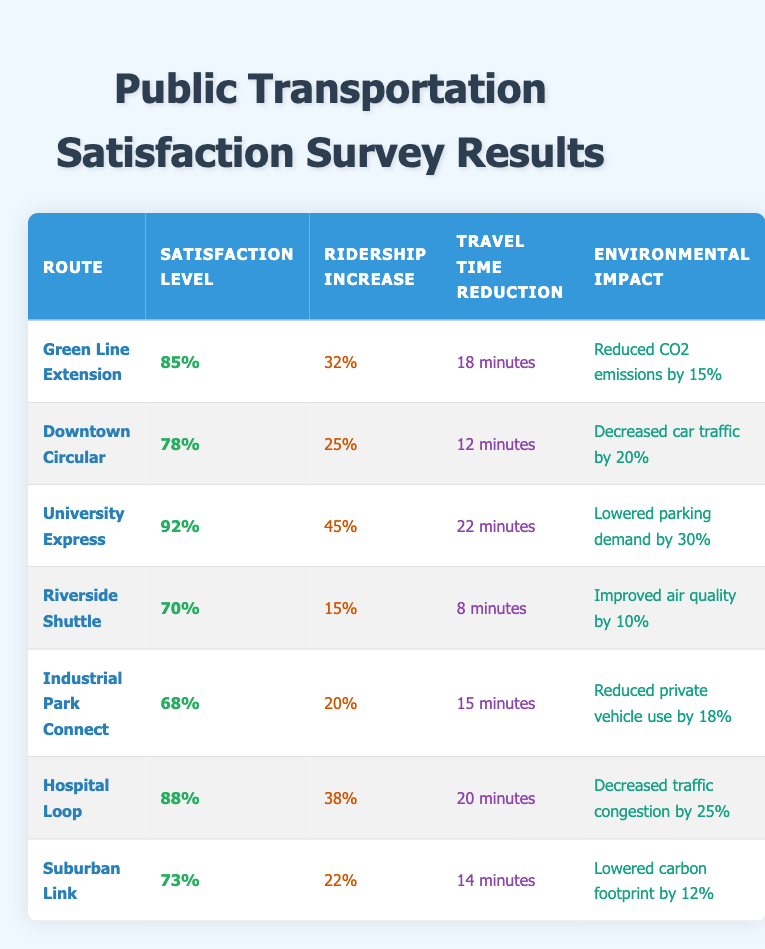What is the satisfaction level for the University Express route? From the table, the satisfaction level for the University Express route is directly listed as 92%.
Answer: 92% Which transportation route had the highest ridership increase? The data shows that the University Express had the highest ridership increase of 45%.
Answer: University Express What is the average travel time reduction for all routes? To find the average travel time reduction, first convert all the time reductions to minutes: 18, 12, 22, 8, 15, 20, 14. The sum is (18 + 12 + 22 + 8 + 15 + 20 + 14) = 119 minutes. There are 7 routes, so the average is 119/7 ≈ 16.71 minutes.
Answer: 16.71 minutes Is the satisfaction level for the Riverside Shuttle greater than 75%? According to the table, the Riverside Shuttle has a satisfaction level of 70%, which is less than 75%.
Answer: No Which route saw a decrease in car traffic and what was the percentage? The Downtown Circular route saw a decrease in car traffic by 20%, as mentioned in the environmental impact column.
Answer: Downtown Circular, 20% What is the difference in satisfaction level between the Green Line Extension and the Hospital Loop? The satisfaction level for the Green Line Extension is 85% and for the Hospital Loop, it is 88%. The difference is calculated as 88% - 85% = 3%.
Answer: 3% Which route has the lowest satisfaction level and what is the percentage? The Industrial Park Connect route has the lowest satisfaction level at 68%, as indicated in the table.
Answer: 68% Was the environmental impact of the Hospital Loop in terms of traffic congestion greater than that of the Riverside Shuttle in terms of air quality? The Hospital Loop decreased traffic congestion by 25%, while the Riverside Shuttle improved air quality by 10%. Since 25% is greater than 10%, the answer is yes.
Answer: Yes 